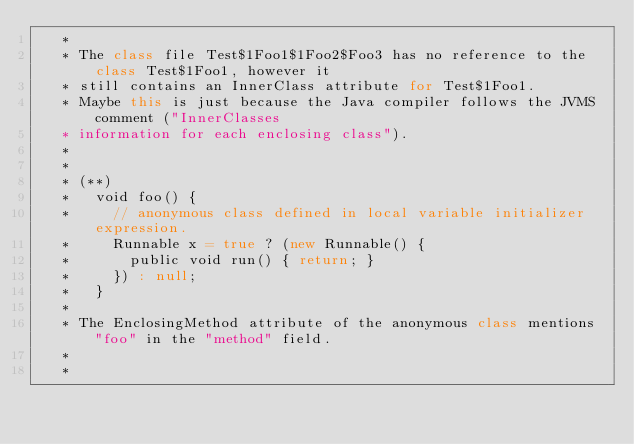<code> <loc_0><loc_0><loc_500><loc_500><_Scala_>   *
   * The class file Test$1Foo1$1Foo2$Foo3 has no reference to the class Test$1Foo1, however it
   * still contains an InnerClass attribute for Test$1Foo1.
   * Maybe this is just because the Java compiler follows the JVMS comment ("InnerClasses
   * information for each enclosing class").
   *
   *
   * (**)
   *   void foo() {
   *     // anonymous class defined in local variable initializer expression.
   *     Runnable x = true ? (new Runnable() {
   *       public void run() { return; }
   *     }) : null;
   *   }
   *
   * The EnclosingMethod attribute of the anonymous class mentions "foo" in the "method" field.
   *
   *</code> 